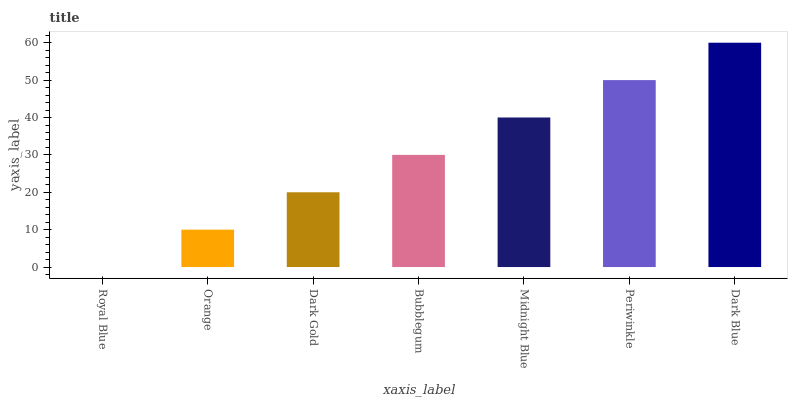Is Royal Blue the minimum?
Answer yes or no. Yes. Is Dark Blue the maximum?
Answer yes or no. Yes. Is Orange the minimum?
Answer yes or no. No. Is Orange the maximum?
Answer yes or no. No. Is Orange greater than Royal Blue?
Answer yes or no. Yes. Is Royal Blue less than Orange?
Answer yes or no. Yes. Is Royal Blue greater than Orange?
Answer yes or no. No. Is Orange less than Royal Blue?
Answer yes or no. No. Is Bubblegum the high median?
Answer yes or no. Yes. Is Bubblegum the low median?
Answer yes or no. Yes. Is Midnight Blue the high median?
Answer yes or no. No. Is Periwinkle the low median?
Answer yes or no. No. 